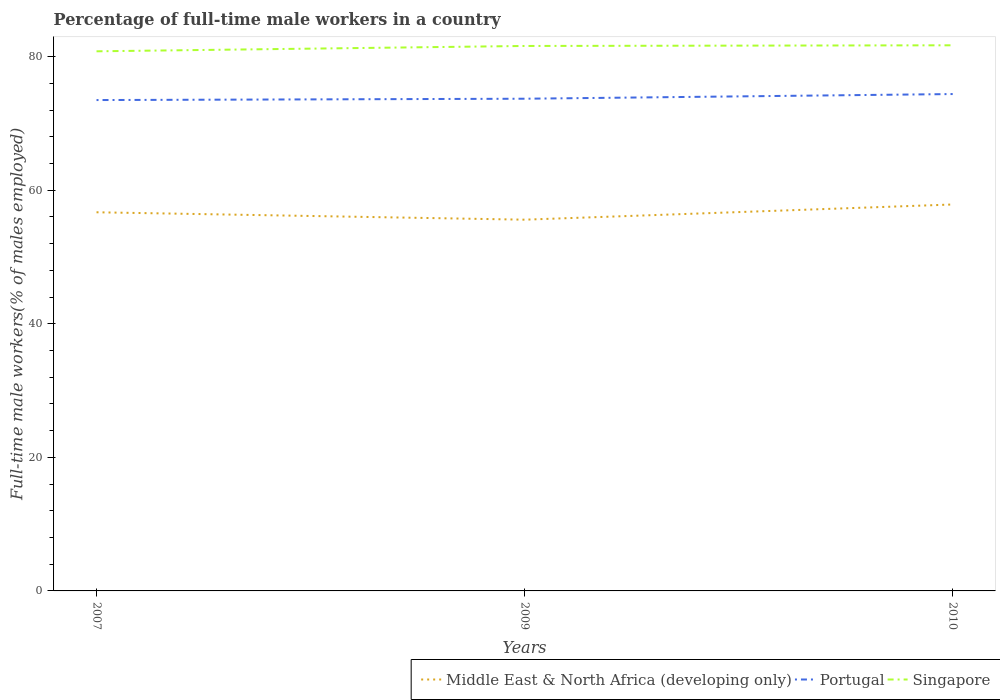Does the line corresponding to Portugal intersect with the line corresponding to Singapore?
Provide a short and direct response. No. Is the number of lines equal to the number of legend labels?
Offer a very short reply. Yes. Across all years, what is the maximum percentage of full-time male workers in Portugal?
Your answer should be compact. 73.5. In which year was the percentage of full-time male workers in Singapore maximum?
Ensure brevity in your answer.  2007. What is the total percentage of full-time male workers in Singapore in the graph?
Provide a short and direct response. -0.8. What is the difference between the highest and the second highest percentage of full-time male workers in Portugal?
Give a very brief answer. 0.9. Is the percentage of full-time male workers in Portugal strictly greater than the percentage of full-time male workers in Middle East & North Africa (developing only) over the years?
Make the answer very short. No. Does the graph contain any zero values?
Your answer should be very brief. No. Does the graph contain grids?
Offer a very short reply. No. How are the legend labels stacked?
Keep it short and to the point. Horizontal. What is the title of the graph?
Keep it short and to the point. Percentage of full-time male workers in a country. What is the label or title of the Y-axis?
Keep it short and to the point. Full-time male workers(% of males employed). What is the Full-time male workers(% of males employed) of Middle East & North Africa (developing only) in 2007?
Keep it short and to the point. 56.7. What is the Full-time male workers(% of males employed) of Portugal in 2007?
Your answer should be very brief. 73.5. What is the Full-time male workers(% of males employed) in Singapore in 2007?
Provide a succinct answer. 80.8. What is the Full-time male workers(% of males employed) of Middle East & North Africa (developing only) in 2009?
Your response must be concise. 55.59. What is the Full-time male workers(% of males employed) in Portugal in 2009?
Your response must be concise. 73.7. What is the Full-time male workers(% of males employed) in Singapore in 2009?
Offer a very short reply. 81.6. What is the Full-time male workers(% of males employed) in Middle East & North Africa (developing only) in 2010?
Offer a very short reply. 57.86. What is the Full-time male workers(% of males employed) in Portugal in 2010?
Provide a succinct answer. 74.4. What is the Full-time male workers(% of males employed) in Singapore in 2010?
Keep it short and to the point. 81.7. Across all years, what is the maximum Full-time male workers(% of males employed) of Middle East & North Africa (developing only)?
Keep it short and to the point. 57.86. Across all years, what is the maximum Full-time male workers(% of males employed) of Portugal?
Your response must be concise. 74.4. Across all years, what is the maximum Full-time male workers(% of males employed) of Singapore?
Your answer should be compact. 81.7. Across all years, what is the minimum Full-time male workers(% of males employed) in Middle East & North Africa (developing only)?
Give a very brief answer. 55.59. Across all years, what is the minimum Full-time male workers(% of males employed) of Portugal?
Give a very brief answer. 73.5. Across all years, what is the minimum Full-time male workers(% of males employed) in Singapore?
Your answer should be very brief. 80.8. What is the total Full-time male workers(% of males employed) of Middle East & North Africa (developing only) in the graph?
Keep it short and to the point. 170.15. What is the total Full-time male workers(% of males employed) of Portugal in the graph?
Your answer should be very brief. 221.6. What is the total Full-time male workers(% of males employed) in Singapore in the graph?
Keep it short and to the point. 244.1. What is the difference between the Full-time male workers(% of males employed) of Middle East & North Africa (developing only) in 2007 and that in 2009?
Ensure brevity in your answer.  1.11. What is the difference between the Full-time male workers(% of males employed) of Portugal in 2007 and that in 2009?
Make the answer very short. -0.2. What is the difference between the Full-time male workers(% of males employed) of Singapore in 2007 and that in 2009?
Your answer should be very brief. -0.8. What is the difference between the Full-time male workers(% of males employed) of Middle East & North Africa (developing only) in 2007 and that in 2010?
Your answer should be compact. -1.17. What is the difference between the Full-time male workers(% of males employed) in Portugal in 2007 and that in 2010?
Give a very brief answer. -0.9. What is the difference between the Full-time male workers(% of males employed) of Singapore in 2007 and that in 2010?
Offer a terse response. -0.9. What is the difference between the Full-time male workers(% of males employed) in Middle East & North Africa (developing only) in 2009 and that in 2010?
Give a very brief answer. -2.27. What is the difference between the Full-time male workers(% of males employed) in Portugal in 2009 and that in 2010?
Keep it short and to the point. -0.7. What is the difference between the Full-time male workers(% of males employed) in Singapore in 2009 and that in 2010?
Make the answer very short. -0.1. What is the difference between the Full-time male workers(% of males employed) in Middle East & North Africa (developing only) in 2007 and the Full-time male workers(% of males employed) in Portugal in 2009?
Your response must be concise. -17. What is the difference between the Full-time male workers(% of males employed) of Middle East & North Africa (developing only) in 2007 and the Full-time male workers(% of males employed) of Singapore in 2009?
Make the answer very short. -24.9. What is the difference between the Full-time male workers(% of males employed) of Portugal in 2007 and the Full-time male workers(% of males employed) of Singapore in 2009?
Provide a succinct answer. -8.1. What is the difference between the Full-time male workers(% of males employed) of Middle East & North Africa (developing only) in 2007 and the Full-time male workers(% of males employed) of Portugal in 2010?
Provide a short and direct response. -17.7. What is the difference between the Full-time male workers(% of males employed) in Middle East & North Africa (developing only) in 2007 and the Full-time male workers(% of males employed) in Singapore in 2010?
Your response must be concise. -25. What is the difference between the Full-time male workers(% of males employed) of Middle East & North Africa (developing only) in 2009 and the Full-time male workers(% of males employed) of Portugal in 2010?
Your response must be concise. -18.81. What is the difference between the Full-time male workers(% of males employed) of Middle East & North Africa (developing only) in 2009 and the Full-time male workers(% of males employed) of Singapore in 2010?
Provide a short and direct response. -26.11. What is the difference between the Full-time male workers(% of males employed) in Portugal in 2009 and the Full-time male workers(% of males employed) in Singapore in 2010?
Keep it short and to the point. -8. What is the average Full-time male workers(% of males employed) of Middle East & North Africa (developing only) per year?
Offer a very short reply. 56.72. What is the average Full-time male workers(% of males employed) of Portugal per year?
Offer a very short reply. 73.87. What is the average Full-time male workers(% of males employed) of Singapore per year?
Ensure brevity in your answer.  81.37. In the year 2007, what is the difference between the Full-time male workers(% of males employed) of Middle East & North Africa (developing only) and Full-time male workers(% of males employed) of Portugal?
Offer a very short reply. -16.8. In the year 2007, what is the difference between the Full-time male workers(% of males employed) of Middle East & North Africa (developing only) and Full-time male workers(% of males employed) of Singapore?
Your answer should be compact. -24.1. In the year 2007, what is the difference between the Full-time male workers(% of males employed) in Portugal and Full-time male workers(% of males employed) in Singapore?
Provide a succinct answer. -7.3. In the year 2009, what is the difference between the Full-time male workers(% of males employed) of Middle East & North Africa (developing only) and Full-time male workers(% of males employed) of Portugal?
Keep it short and to the point. -18.11. In the year 2009, what is the difference between the Full-time male workers(% of males employed) in Middle East & North Africa (developing only) and Full-time male workers(% of males employed) in Singapore?
Your answer should be very brief. -26.01. In the year 2009, what is the difference between the Full-time male workers(% of males employed) in Portugal and Full-time male workers(% of males employed) in Singapore?
Keep it short and to the point. -7.9. In the year 2010, what is the difference between the Full-time male workers(% of males employed) in Middle East & North Africa (developing only) and Full-time male workers(% of males employed) in Portugal?
Your response must be concise. -16.54. In the year 2010, what is the difference between the Full-time male workers(% of males employed) of Middle East & North Africa (developing only) and Full-time male workers(% of males employed) of Singapore?
Ensure brevity in your answer.  -23.84. What is the ratio of the Full-time male workers(% of males employed) of Middle East & North Africa (developing only) in 2007 to that in 2009?
Make the answer very short. 1.02. What is the ratio of the Full-time male workers(% of males employed) in Portugal in 2007 to that in 2009?
Ensure brevity in your answer.  1. What is the ratio of the Full-time male workers(% of males employed) in Singapore in 2007 to that in 2009?
Offer a very short reply. 0.99. What is the ratio of the Full-time male workers(% of males employed) in Middle East & North Africa (developing only) in 2007 to that in 2010?
Your answer should be compact. 0.98. What is the ratio of the Full-time male workers(% of males employed) of Portugal in 2007 to that in 2010?
Provide a succinct answer. 0.99. What is the ratio of the Full-time male workers(% of males employed) of Middle East & North Africa (developing only) in 2009 to that in 2010?
Your response must be concise. 0.96. What is the ratio of the Full-time male workers(% of males employed) of Portugal in 2009 to that in 2010?
Provide a short and direct response. 0.99. What is the difference between the highest and the second highest Full-time male workers(% of males employed) of Middle East & North Africa (developing only)?
Your response must be concise. 1.17. What is the difference between the highest and the second highest Full-time male workers(% of males employed) of Portugal?
Ensure brevity in your answer.  0.7. What is the difference between the highest and the second highest Full-time male workers(% of males employed) in Singapore?
Provide a short and direct response. 0.1. What is the difference between the highest and the lowest Full-time male workers(% of males employed) of Middle East & North Africa (developing only)?
Your answer should be very brief. 2.27. What is the difference between the highest and the lowest Full-time male workers(% of males employed) in Portugal?
Keep it short and to the point. 0.9. What is the difference between the highest and the lowest Full-time male workers(% of males employed) in Singapore?
Provide a short and direct response. 0.9. 